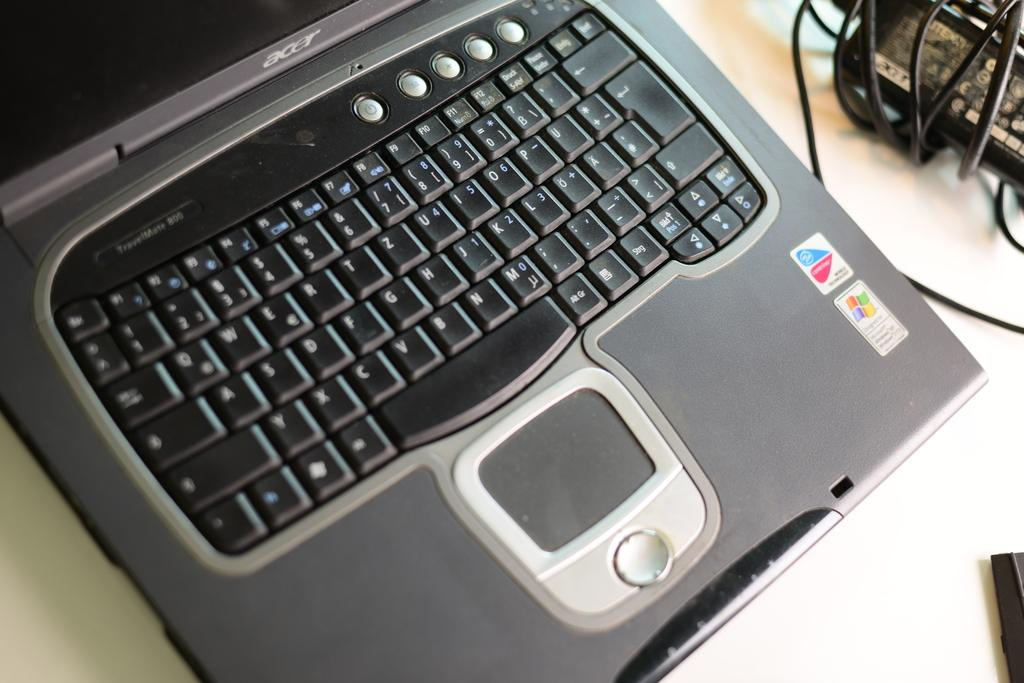<image>
Describe the image concisely. An Acer computer is open and has a black keyboard. 